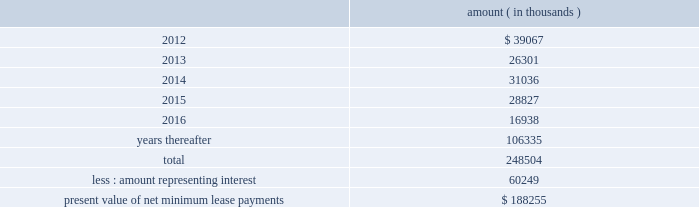Entergy corporation and subsidiaries notes to financial statements sale and leaseback transactions waterford 3 lease obligations in 1989 , in three separate but substantially identical transactions , entergy louisiana sold and leased back undivided interests in waterford 3 for the aggregate sum of $ 353.6 million .
The interests represent approximately 9.3% ( 9.3 % ) of waterford 3 .
The leases expire in 2017 .
Under certain circumstances , entergy louisiana may repurchase the leased interests prior to the end of the term of the leases .
At the end of the lease terms , entergy louisiana has the option to repurchase the leased interests in waterford 3 at fair market value or to renew the leases for either fair market value or , under certain conditions , a fixed rate .
Entergy louisiana issued $ 208.2 million of non-interest bearing first mortgage bonds as collateral for the equity portion of certain amounts payable under the leases .
Upon the occurrence of certain events , entergy louisiana may be obligated to assume the outstanding bonds used to finance the purchase of the interests in the unit and to pay an amount sufficient to withdraw from the lease transaction .
Such events include lease events of default , events of loss , deemed loss events , or certain adverse 201cfinancial events . 201d 201cfinancial events 201d include , among other things , failure by entergy louisiana , following the expiration of any applicable grace or cure period , to maintain ( i ) total equity capital ( including preferred membership interests ) at least equal to 30% ( 30 % ) of adjusted capitalization , or ( ii ) a fixed charge coverage ratio of at least 1.50 computed on a rolling 12 month basis .
As of december 31 , 2011 , entergy louisiana was in compliance with these provisions .
As of december 31 , 2011 , entergy louisiana had future minimum lease payments ( reflecting an overall implicit rate of 7.45% ( 7.45 % ) ) in connection with the waterford 3 sale and leaseback transactions , which are recorded as long-term debt , as follows : amount ( in thousands ) .
Grand gulf lease obligations in 1988 , in two separate but substantially identical transactions , system energy sold and leased back undivided ownership interests in grand gulf for the aggregate sum of $ 500 million .
The interests represent approximately 11.5% ( 11.5 % ) of grand gulf .
The leases expire in 2015 .
Under certain circumstances , system entergy may repurchase the leased interests prior to the end of the term of the leases .
At the end of the lease terms , system energy has the option to repurchase the leased interests in grand gulf at fair market value or to renew the leases for either fair market value or , under certain conditions , a fixed rate .
System energy is required to report the sale-leaseback as a financing transaction in its financial statements .
For financial reporting purposes , system energy expenses the interest portion of the lease obligation and the plant depreciation .
However , operating revenues include the recovery of the lease payments because the transactions are accounted for as a sale and leaseback for ratemaking purposes .
Consistent with a recommendation contained in a .
What portion of the total future minimum lease payments is expected to go for interest? 
Computations: (60249 / 248504)
Answer: 0.24245. 